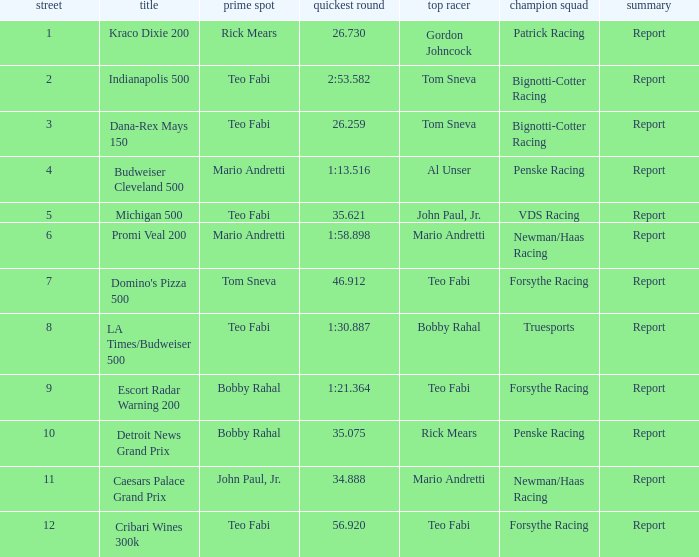How many reports are there in the race that Forsythe Racing won and Teo Fabi had the pole position in? 1.0. 